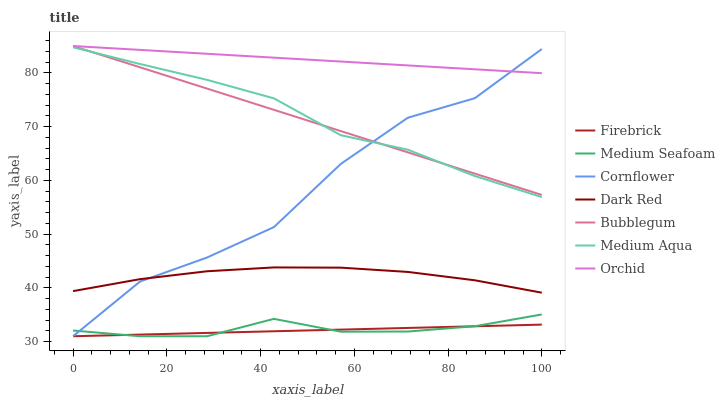Does Firebrick have the minimum area under the curve?
Answer yes or no. Yes. Does Orchid have the maximum area under the curve?
Answer yes or no. Yes. Does Dark Red have the minimum area under the curve?
Answer yes or no. No. Does Dark Red have the maximum area under the curve?
Answer yes or no. No. Is Bubblegum the smoothest?
Answer yes or no. Yes. Is Cornflower the roughest?
Answer yes or no. Yes. Is Dark Red the smoothest?
Answer yes or no. No. Is Dark Red the roughest?
Answer yes or no. No. Does Cornflower have the lowest value?
Answer yes or no. Yes. Does Dark Red have the lowest value?
Answer yes or no. No. Does Orchid have the highest value?
Answer yes or no. Yes. Does Dark Red have the highest value?
Answer yes or no. No. Is Medium Seafoam less than Medium Aqua?
Answer yes or no. Yes. Is Medium Aqua greater than Medium Seafoam?
Answer yes or no. Yes. Does Firebrick intersect Medium Seafoam?
Answer yes or no. Yes. Is Firebrick less than Medium Seafoam?
Answer yes or no. No. Is Firebrick greater than Medium Seafoam?
Answer yes or no. No. Does Medium Seafoam intersect Medium Aqua?
Answer yes or no. No. 